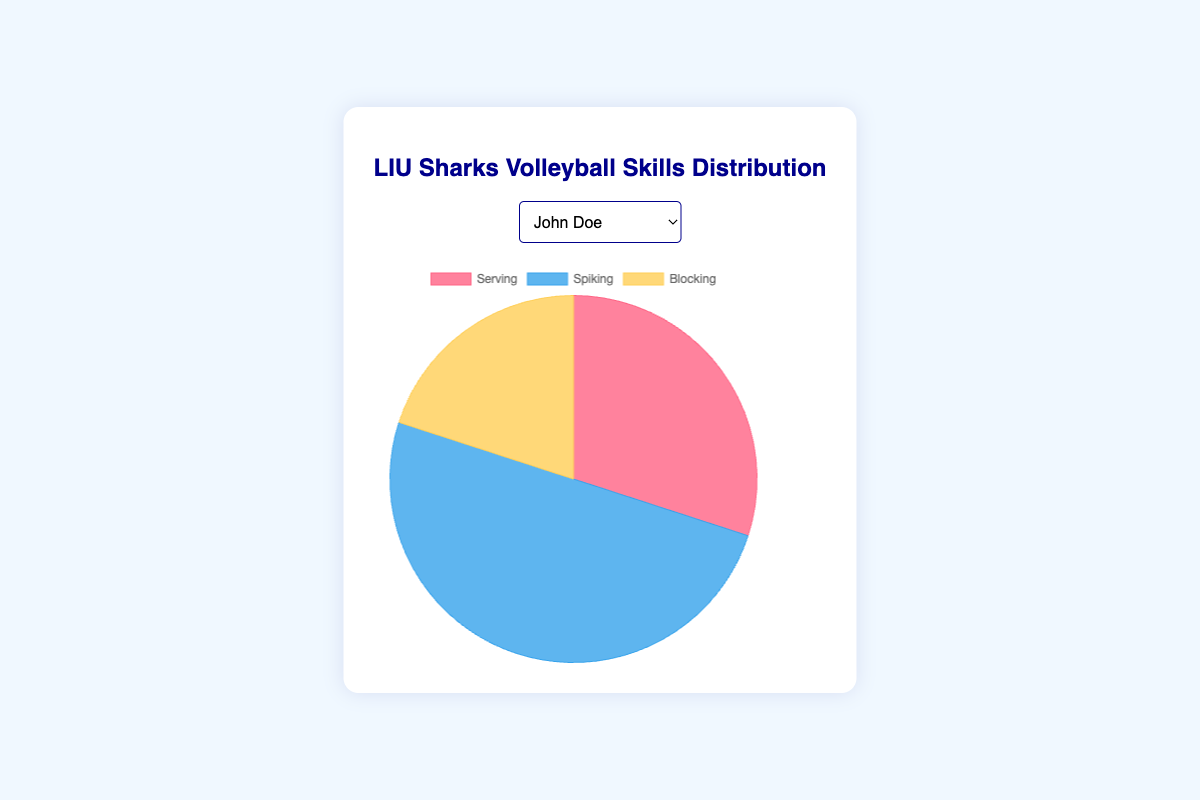How much time does Alex Smith spend on Serving and Spiking combined? To find the combined time, add the time spent on Serving (25) and Spiking (55). 25 + 55 = 80
Answer: 80 Who spends the most time on Spiking? Compare the time spent on Spiking by each player: John Doe (50), Alex Smith (55), Michael Johnson (60), Chris Brown (45), and David Garcia (52). Michael Johnson has the highest value (60).
Answer: Michael Johnson What is the visual color representing Blocking across all players? In the pie chart, Blocking is consistently represented by the color yellow.
Answer: Yellow Is the time spent on Blocking the same for all players? Check the time spent on Blocking for each player: John Doe (20), Alex Smith (20), Michael Johnson (20), Chris Brown (20), and David Garcia (20). All values are equal to 20, so, yes, it is the same.
Answer: Yes What is the average time spent on Serving across all players? Add the Serving times for all players (30 + 25 + 20 + 35 + 28), then divide by the number of players (5). The total is 138, and 138 divided by 5 is 27.6.
Answer: 27.6 Which player spends the least time on Serving? Compare the time spent on Serving by each player: John Doe (30), Alex Smith (25), Michael Johnson (20), Chris Brown (35), David Garcia (28). Michael Johnson has the lowest value (20).
Answer: Michael Johnson How does the time spent on Spiking by Chris Brown compare to that of David Garcia? Chris Brown spends 45 minutes, whereas David Garcia spends 52 minutes on Spiking. 45 is less than 52.
Answer: Chris Brown spends less time What is the ratio of time spent on Spiking to Blocking for John Doe? Calculate the ratio of Spiking (50) to Blocking (20). 50 divided by 20 is 2.5.
Answer: 2.5 What percentage of the total time does Michael Johnson spend on Blocking? The total time for Michael Johnson is 100 minutes (20 + 60 + 20). Blocking time is 20, so the percentage is (20/100) * 100% = 20%.
Answer: 20% Which player spends exactly 35 minutes on Serving? Check the Serving time for each player: John Doe (30), Alex Smith (25), Michael Johnson (20), Chris Brown (35), David Garcia (28). Chris Brown is the player who spends exactly 35 minutes.
Answer: Chris Brown 